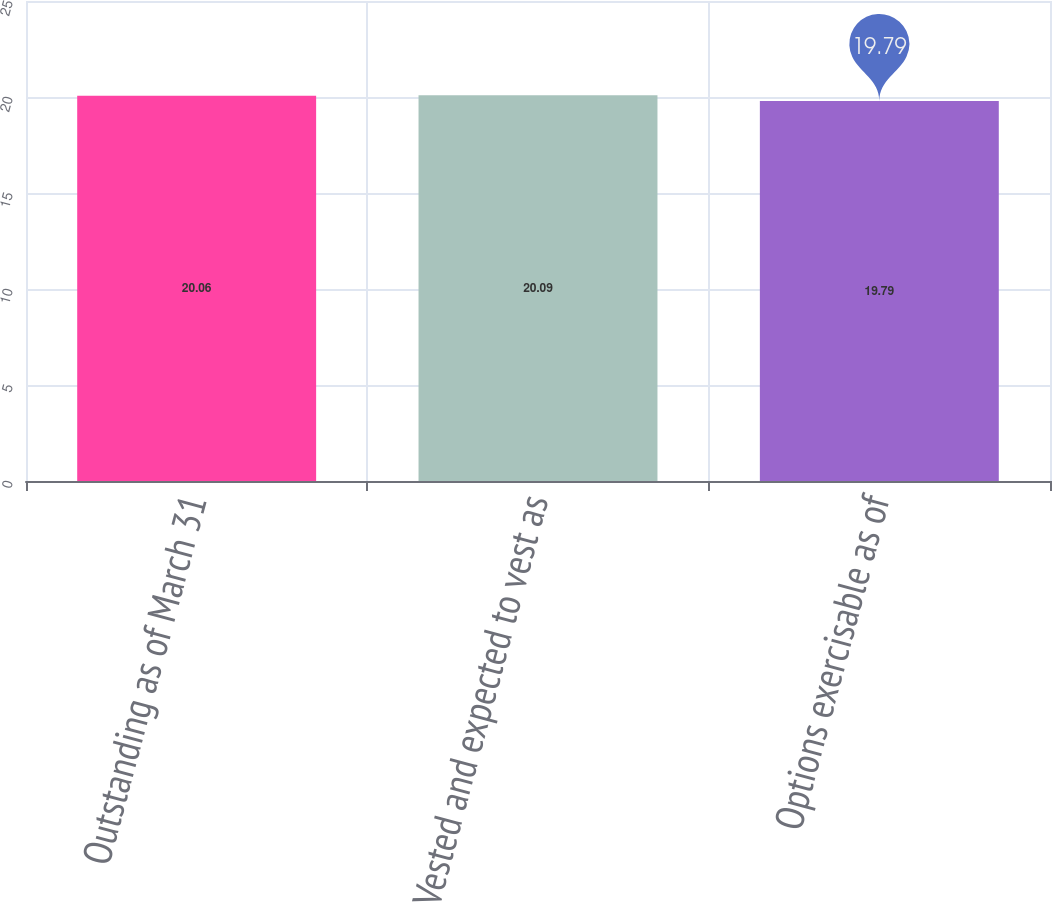Convert chart to OTSL. <chart><loc_0><loc_0><loc_500><loc_500><bar_chart><fcel>Outstanding as of March 31<fcel>Vested and expected to vest as<fcel>Options exercisable as of<nl><fcel>20.06<fcel>20.09<fcel>19.79<nl></chart> 